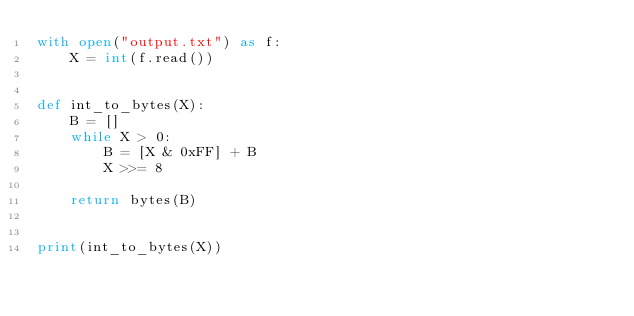<code> <loc_0><loc_0><loc_500><loc_500><_Python_>with open("output.txt") as f:
    X = int(f.read())


def int_to_bytes(X):
    B = []
    while X > 0:
        B = [X & 0xFF] + B
        X >>= 8

    return bytes(B)


print(int_to_bytes(X))
</code> 